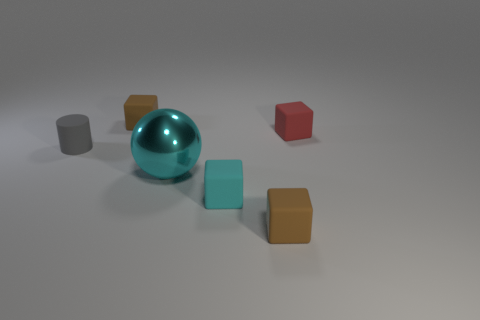Subtract all cyan blocks. How many blocks are left? 3 Add 2 small cyan rubber spheres. How many objects exist? 8 Subtract all yellow spheres. How many brown blocks are left? 2 Subtract all red blocks. How many blocks are left? 3 Subtract all balls. How many objects are left? 5 Subtract 1 spheres. How many spheres are left? 0 Subtract all yellow blocks. Subtract all red cylinders. How many blocks are left? 4 Subtract all gray rubber cylinders. Subtract all cubes. How many objects are left? 1 Add 4 tiny cyan objects. How many tiny cyan objects are left? 5 Add 6 tiny rubber cylinders. How many tiny rubber cylinders exist? 7 